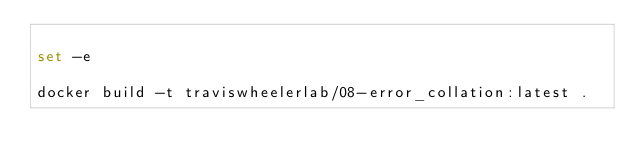Convert code to text. <code><loc_0><loc_0><loc_500><loc_500><_Bash_>
set -e

docker build -t traviswheelerlab/08-error_collation:latest .
</code> 